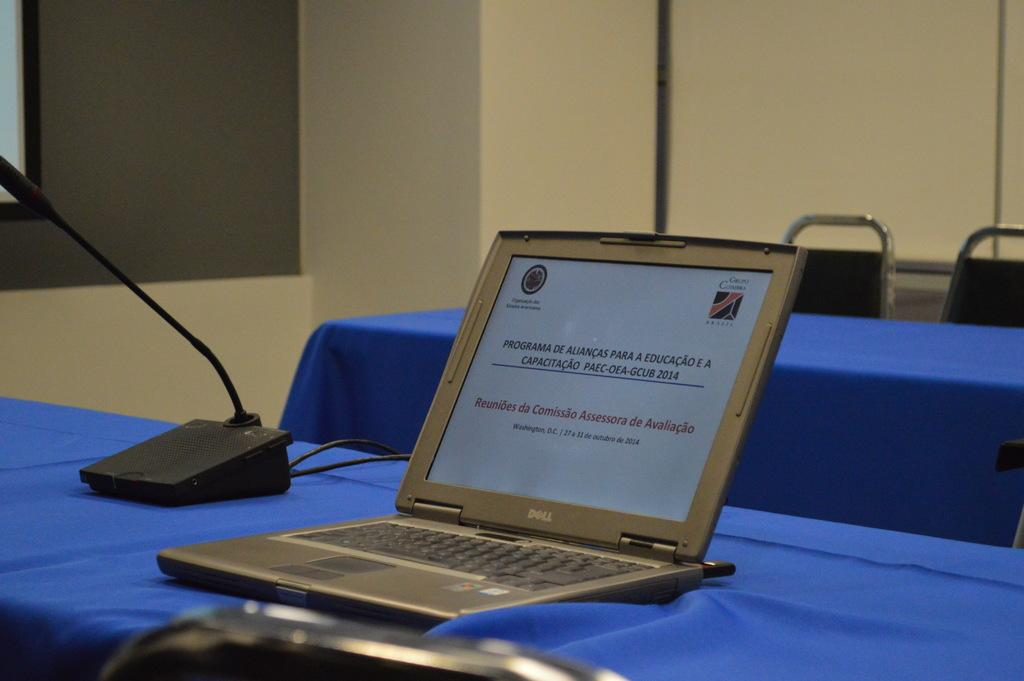<image>
Summarize the visual content of the image. a Dell computer sits on a blue table by itself 